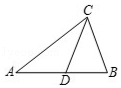First perform reasoning, then finally select the question from the choices in the following format: Answer: xxx.
Question: In triangle ABC, given that CD is the midline, AB is 40 units long, what is the length of AD?
Choices:
A: 20.0
B: 24.0
C: 32.0
D: 16.0 Since CD is the median of triangle ABC according to the diagram and AB = 40, therefore AD = BD = 1/2 AB = 20.[Answer] Solution: Since CD is the median of triangle ABC according to the diagram and AB = 10, therefore AD = BD = 1/2 AB = 5.
Answer:A 